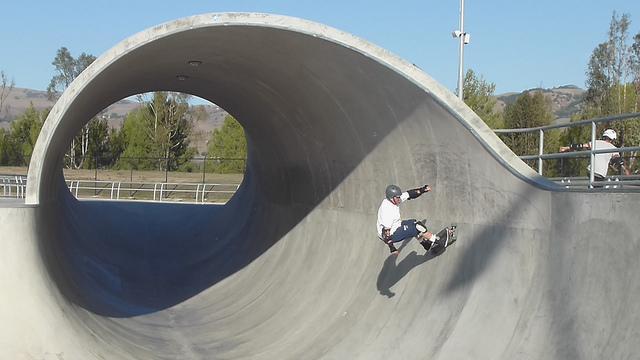How many people are in the picture?
Give a very brief answer. 2. How many skateboard are there?
Give a very brief answer. 1. How many orange cars are there in the picture?
Give a very brief answer. 0. 